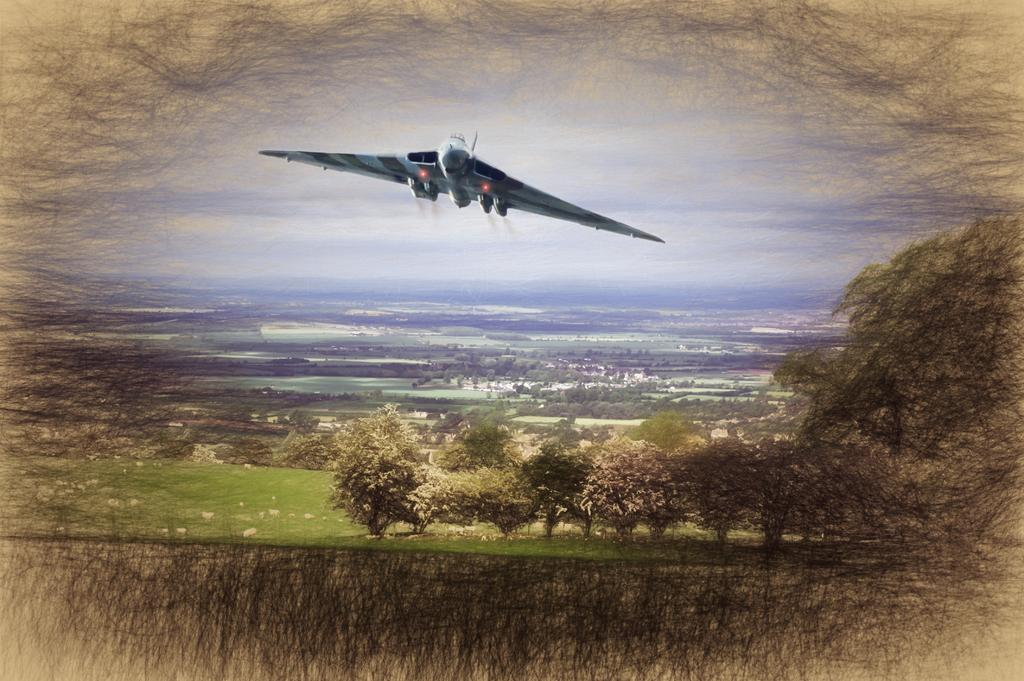How can you tell that the image has been edited? The image is edited, as indicated by the provided fact. What is the main subject in the middle of the image? There is an airplane flying in the middle of the image. What type of vegetation is present at the bottom of the image? There are many trees on the ground at the bottom of the image. What can be seen in the background of the image? The sky is visible in the background of the image. How many rabbits can be seen eating honey in the image? There are no rabbits or honey present in the image; it features an airplane flying over trees with a visible sky in the background. What type of bird is perched on the robin in the image? There is no bird, specifically a robin, present in the image. 